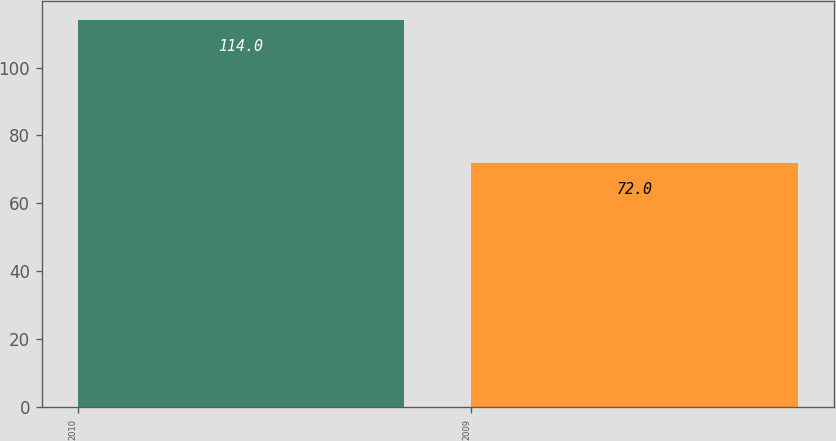Convert chart to OTSL. <chart><loc_0><loc_0><loc_500><loc_500><bar_chart><fcel>2010<fcel>2009<nl><fcel>114<fcel>72<nl></chart> 